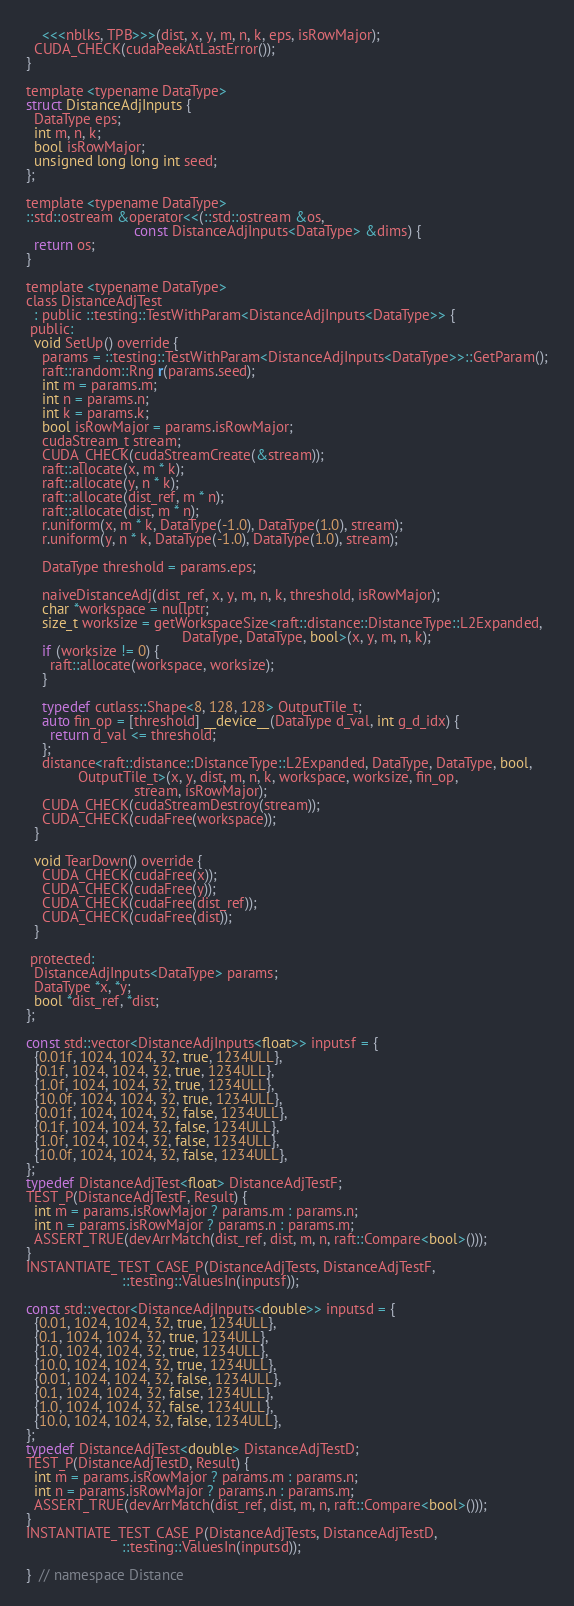<code> <loc_0><loc_0><loc_500><loc_500><_Cuda_>    <<<nblks, TPB>>>(dist, x, y, m, n, k, eps, isRowMajor);
  CUDA_CHECK(cudaPeekAtLastError());
}

template <typename DataType>
struct DistanceAdjInputs {
  DataType eps;
  int m, n, k;
  bool isRowMajor;
  unsigned long long int seed;
};

template <typename DataType>
::std::ostream &operator<<(::std::ostream &os,
                           const DistanceAdjInputs<DataType> &dims) {
  return os;
}

template <typename DataType>
class DistanceAdjTest
  : public ::testing::TestWithParam<DistanceAdjInputs<DataType>> {
 public:
  void SetUp() override {
    params = ::testing::TestWithParam<DistanceAdjInputs<DataType>>::GetParam();
    raft::random::Rng r(params.seed);
    int m = params.m;
    int n = params.n;
    int k = params.k;
    bool isRowMajor = params.isRowMajor;
    cudaStream_t stream;
    CUDA_CHECK(cudaStreamCreate(&stream));
    raft::allocate(x, m * k);
    raft::allocate(y, n * k);
    raft::allocate(dist_ref, m * n);
    raft::allocate(dist, m * n);
    r.uniform(x, m * k, DataType(-1.0), DataType(1.0), stream);
    r.uniform(y, n * k, DataType(-1.0), DataType(1.0), stream);

    DataType threshold = params.eps;

    naiveDistanceAdj(dist_ref, x, y, m, n, k, threshold, isRowMajor);
    char *workspace = nullptr;
    size_t worksize = getWorkspaceSize<raft::distance::DistanceType::L2Expanded,
                                       DataType, DataType, bool>(x, y, m, n, k);
    if (worksize != 0) {
      raft::allocate(workspace, worksize);
    }

    typedef cutlass::Shape<8, 128, 128> OutputTile_t;
    auto fin_op = [threshold] __device__(DataType d_val, int g_d_idx) {
      return d_val <= threshold;
    };
    distance<raft::distance::DistanceType::L2Expanded, DataType, DataType, bool,
             OutputTile_t>(x, y, dist, m, n, k, workspace, worksize, fin_op,
                           stream, isRowMajor);
    CUDA_CHECK(cudaStreamDestroy(stream));
    CUDA_CHECK(cudaFree(workspace));
  }

  void TearDown() override {
    CUDA_CHECK(cudaFree(x));
    CUDA_CHECK(cudaFree(y));
    CUDA_CHECK(cudaFree(dist_ref));
    CUDA_CHECK(cudaFree(dist));
  }

 protected:
  DistanceAdjInputs<DataType> params;
  DataType *x, *y;
  bool *dist_ref, *dist;
};

const std::vector<DistanceAdjInputs<float>> inputsf = {
  {0.01f, 1024, 1024, 32, true, 1234ULL},
  {0.1f, 1024, 1024, 32, true, 1234ULL},
  {1.0f, 1024, 1024, 32, true, 1234ULL},
  {10.0f, 1024, 1024, 32, true, 1234ULL},
  {0.01f, 1024, 1024, 32, false, 1234ULL},
  {0.1f, 1024, 1024, 32, false, 1234ULL},
  {1.0f, 1024, 1024, 32, false, 1234ULL},
  {10.0f, 1024, 1024, 32, false, 1234ULL},
};
typedef DistanceAdjTest<float> DistanceAdjTestF;
TEST_P(DistanceAdjTestF, Result) {
  int m = params.isRowMajor ? params.m : params.n;
  int n = params.isRowMajor ? params.n : params.m;
  ASSERT_TRUE(devArrMatch(dist_ref, dist, m, n, raft::Compare<bool>()));
}
INSTANTIATE_TEST_CASE_P(DistanceAdjTests, DistanceAdjTestF,
                        ::testing::ValuesIn(inputsf));

const std::vector<DistanceAdjInputs<double>> inputsd = {
  {0.01, 1024, 1024, 32, true, 1234ULL},
  {0.1, 1024, 1024, 32, true, 1234ULL},
  {1.0, 1024, 1024, 32, true, 1234ULL},
  {10.0, 1024, 1024, 32, true, 1234ULL},
  {0.01, 1024, 1024, 32, false, 1234ULL},
  {0.1, 1024, 1024, 32, false, 1234ULL},
  {1.0, 1024, 1024, 32, false, 1234ULL},
  {10.0, 1024, 1024, 32, false, 1234ULL},
};
typedef DistanceAdjTest<double> DistanceAdjTestD;
TEST_P(DistanceAdjTestD, Result) {
  int m = params.isRowMajor ? params.m : params.n;
  int n = params.isRowMajor ? params.n : params.m;
  ASSERT_TRUE(devArrMatch(dist_ref, dist, m, n, raft::Compare<bool>()));
}
INSTANTIATE_TEST_CASE_P(DistanceAdjTests, DistanceAdjTestD,
                        ::testing::ValuesIn(inputsd));

}  // namespace Distance</code> 